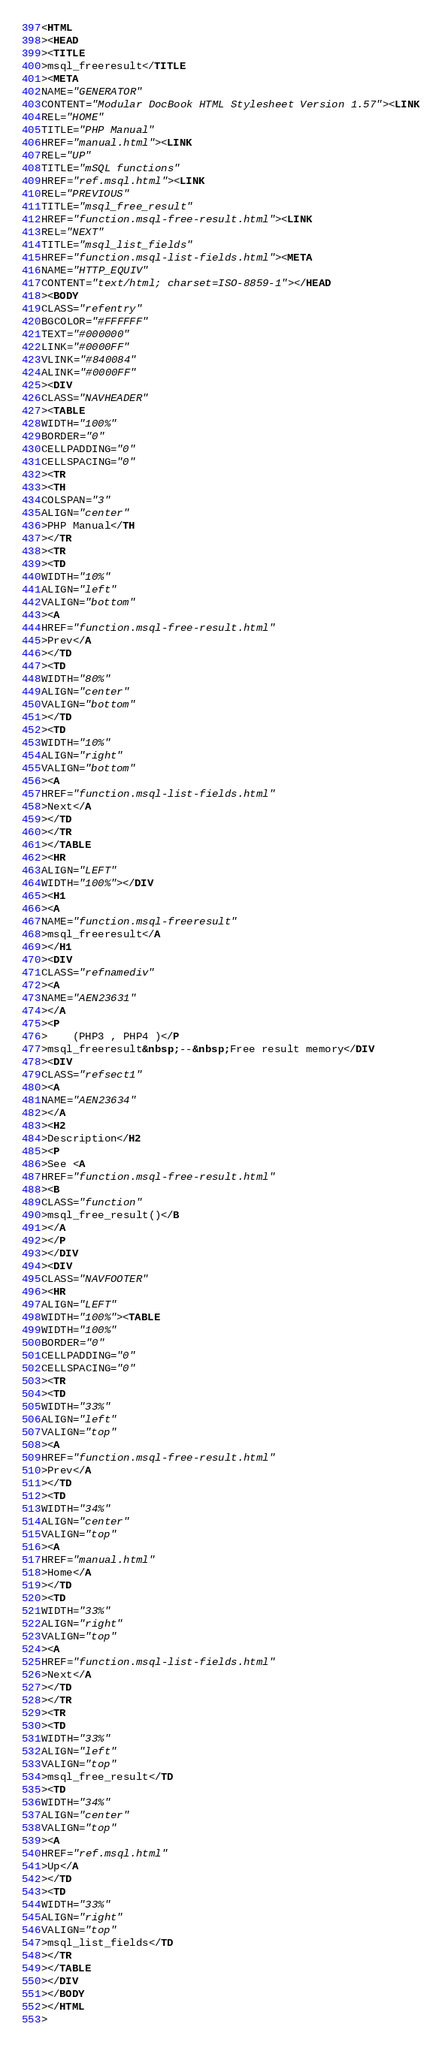Convert code to text. <code><loc_0><loc_0><loc_500><loc_500><_HTML_><HTML
><HEAD
><TITLE
>msql_freeresult</TITLE
><META
NAME="GENERATOR"
CONTENT="Modular DocBook HTML Stylesheet Version 1.57"><LINK
REL="HOME"
TITLE="PHP Manual"
HREF="manual.html"><LINK
REL="UP"
TITLE="mSQL functions"
HREF="ref.msql.html"><LINK
REL="PREVIOUS"
TITLE="msql_free_result"
HREF="function.msql-free-result.html"><LINK
REL="NEXT"
TITLE="msql_list_fields"
HREF="function.msql-list-fields.html"><META
NAME="HTTP_EQUIV"
CONTENT="text/html; charset=ISO-8859-1"></HEAD
><BODY
CLASS="refentry"
BGCOLOR="#FFFFFF"
TEXT="#000000"
LINK="#0000FF"
VLINK="#840084"
ALINK="#0000FF"
><DIV
CLASS="NAVHEADER"
><TABLE
WIDTH="100%"
BORDER="0"
CELLPADDING="0"
CELLSPACING="0"
><TR
><TH
COLSPAN="3"
ALIGN="center"
>PHP Manual</TH
></TR
><TR
><TD
WIDTH="10%"
ALIGN="left"
VALIGN="bottom"
><A
HREF="function.msql-free-result.html"
>Prev</A
></TD
><TD
WIDTH="80%"
ALIGN="center"
VALIGN="bottom"
></TD
><TD
WIDTH="10%"
ALIGN="right"
VALIGN="bottom"
><A
HREF="function.msql-list-fields.html"
>Next</A
></TD
></TR
></TABLE
><HR
ALIGN="LEFT"
WIDTH="100%"></DIV
><H1
><A
NAME="function.msql-freeresult"
>msql_freeresult</A
></H1
><DIV
CLASS="refnamediv"
><A
NAME="AEN23631"
></A
><P
>    (PHP3 , PHP4 )</P
>msql_freeresult&nbsp;--&nbsp;Free result memory</DIV
><DIV
CLASS="refsect1"
><A
NAME="AEN23634"
></A
><H2
>Description</H2
><P
>See <A
HREF="function.msql-free-result.html"
><B
CLASS="function"
>msql_free_result()</B
></A
></P
></DIV
><DIV
CLASS="NAVFOOTER"
><HR
ALIGN="LEFT"
WIDTH="100%"><TABLE
WIDTH="100%"
BORDER="0"
CELLPADDING="0"
CELLSPACING="0"
><TR
><TD
WIDTH="33%"
ALIGN="left"
VALIGN="top"
><A
HREF="function.msql-free-result.html"
>Prev</A
></TD
><TD
WIDTH="34%"
ALIGN="center"
VALIGN="top"
><A
HREF="manual.html"
>Home</A
></TD
><TD
WIDTH="33%"
ALIGN="right"
VALIGN="top"
><A
HREF="function.msql-list-fields.html"
>Next</A
></TD
></TR
><TR
><TD
WIDTH="33%"
ALIGN="left"
VALIGN="top"
>msql_free_result</TD
><TD
WIDTH="34%"
ALIGN="center"
VALIGN="top"
><A
HREF="ref.msql.html"
>Up</A
></TD
><TD
WIDTH="33%"
ALIGN="right"
VALIGN="top"
>msql_list_fields</TD
></TR
></TABLE
></DIV
></BODY
></HTML
></code> 